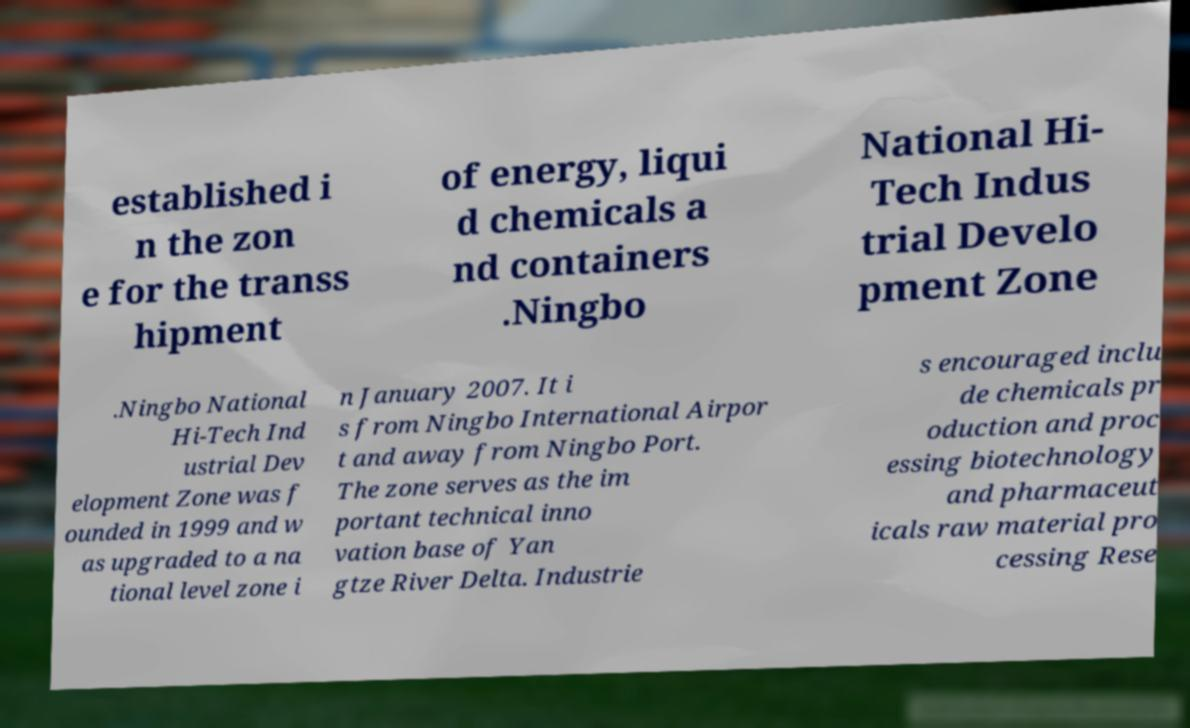Can you read and provide the text displayed in the image?This photo seems to have some interesting text. Can you extract and type it out for me? established i n the zon e for the transs hipment of energy, liqui d chemicals a nd containers .Ningbo National Hi- Tech Indus trial Develo pment Zone .Ningbo National Hi-Tech Ind ustrial Dev elopment Zone was f ounded in 1999 and w as upgraded to a na tional level zone i n January 2007. It i s from Ningbo International Airpor t and away from Ningbo Port. The zone serves as the im portant technical inno vation base of Yan gtze River Delta. Industrie s encouraged inclu de chemicals pr oduction and proc essing biotechnology and pharmaceut icals raw material pro cessing Rese 